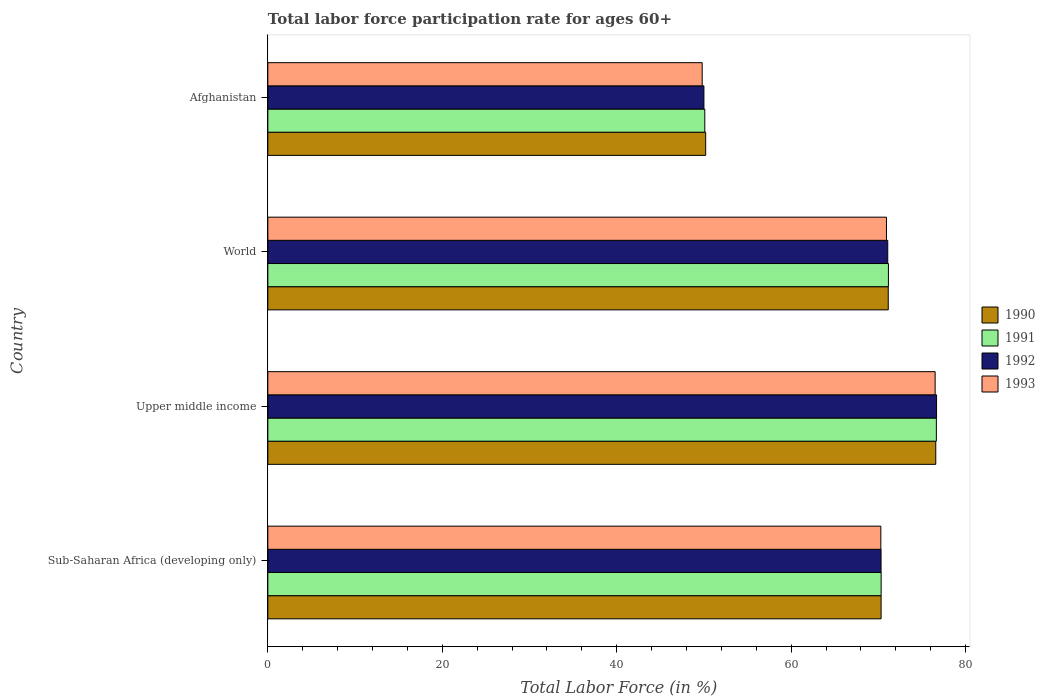How many different coloured bars are there?
Make the answer very short. 4. Are the number of bars per tick equal to the number of legend labels?
Your response must be concise. Yes. What is the label of the 4th group of bars from the top?
Provide a succinct answer. Sub-Saharan Africa (developing only). What is the labor force participation rate in 1991 in World?
Your answer should be compact. 71.15. Across all countries, what is the maximum labor force participation rate in 1993?
Make the answer very short. 76.51. Across all countries, what is the minimum labor force participation rate in 1993?
Offer a very short reply. 49.8. In which country was the labor force participation rate in 1990 maximum?
Give a very brief answer. Upper middle income. In which country was the labor force participation rate in 1991 minimum?
Give a very brief answer. Afghanistan. What is the total labor force participation rate in 1990 in the graph?
Offer a very short reply. 268.23. What is the difference between the labor force participation rate in 1990 in Upper middle income and that in World?
Offer a very short reply. 5.45. What is the difference between the labor force participation rate in 1993 in Sub-Saharan Africa (developing only) and the labor force participation rate in 1990 in Afghanistan?
Provide a short and direct response. 20.08. What is the average labor force participation rate in 1993 per country?
Your answer should be very brief. 66.88. What is the difference between the labor force participation rate in 1993 and labor force participation rate in 1991 in World?
Provide a succinct answer. -0.22. In how many countries, is the labor force participation rate in 1991 greater than 60 %?
Offer a terse response. 3. What is the ratio of the labor force participation rate in 1990 in Sub-Saharan Africa (developing only) to that in Upper middle income?
Keep it short and to the point. 0.92. Is the labor force participation rate in 1992 in Afghanistan less than that in World?
Provide a succinct answer. Yes. Is the difference between the labor force participation rate in 1993 in Afghanistan and World greater than the difference between the labor force participation rate in 1991 in Afghanistan and World?
Provide a short and direct response. No. What is the difference between the highest and the second highest labor force participation rate in 1992?
Your answer should be compact. 5.6. What is the difference between the highest and the lowest labor force participation rate in 1991?
Keep it short and to the point. 26.55. Is the sum of the labor force participation rate in 1992 in Sub-Saharan Africa (developing only) and Upper middle income greater than the maximum labor force participation rate in 1993 across all countries?
Provide a short and direct response. Yes. Is it the case that in every country, the sum of the labor force participation rate in 1993 and labor force participation rate in 1992 is greater than the sum of labor force participation rate in 1991 and labor force participation rate in 1990?
Provide a short and direct response. No. What does the 4th bar from the top in World represents?
Ensure brevity in your answer.  1990. What does the 1st bar from the bottom in Upper middle income represents?
Make the answer very short. 1990. Is it the case that in every country, the sum of the labor force participation rate in 1991 and labor force participation rate in 1993 is greater than the labor force participation rate in 1992?
Provide a succinct answer. Yes. How many bars are there?
Give a very brief answer. 16. Are all the bars in the graph horizontal?
Ensure brevity in your answer.  Yes. What is the difference between two consecutive major ticks on the X-axis?
Offer a terse response. 20. Does the graph contain any zero values?
Offer a terse response. No. Does the graph contain grids?
Give a very brief answer. No. How many legend labels are there?
Offer a terse response. 4. How are the legend labels stacked?
Your answer should be compact. Vertical. What is the title of the graph?
Your answer should be very brief. Total labor force participation rate for ages 60+. What is the label or title of the Y-axis?
Ensure brevity in your answer.  Country. What is the Total Labor Force (in %) of 1990 in Sub-Saharan Africa (developing only)?
Make the answer very short. 70.31. What is the Total Labor Force (in %) in 1991 in Sub-Saharan Africa (developing only)?
Your response must be concise. 70.32. What is the Total Labor Force (in %) in 1992 in Sub-Saharan Africa (developing only)?
Provide a succinct answer. 70.31. What is the Total Labor Force (in %) in 1993 in Sub-Saharan Africa (developing only)?
Make the answer very short. 70.28. What is the Total Labor Force (in %) in 1990 in Upper middle income?
Offer a terse response. 76.58. What is the Total Labor Force (in %) in 1991 in Upper middle income?
Offer a very short reply. 76.65. What is the Total Labor Force (in %) in 1992 in Upper middle income?
Provide a short and direct response. 76.67. What is the Total Labor Force (in %) in 1993 in Upper middle income?
Ensure brevity in your answer.  76.51. What is the Total Labor Force (in %) in 1990 in World?
Keep it short and to the point. 71.13. What is the Total Labor Force (in %) of 1991 in World?
Provide a succinct answer. 71.15. What is the Total Labor Force (in %) in 1992 in World?
Your response must be concise. 71.08. What is the Total Labor Force (in %) of 1993 in World?
Make the answer very short. 70.93. What is the Total Labor Force (in %) in 1990 in Afghanistan?
Offer a terse response. 50.2. What is the Total Labor Force (in %) of 1991 in Afghanistan?
Keep it short and to the point. 50.1. What is the Total Labor Force (in %) of 1992 in Afghanistan?
Your answer should be compact. 50. What is the Total Labor Force (in %) of 1993 in Afghanistan?
Provide a succinct answer. 49.8. Across all countries, what is the maximum Total Labor Force (in %) in 1990?
Offer a terse response. 76.58. Across all countries, what is the maximum Total Labor Force (in %) of 1991?
Offer a very short reply. 76.65. Across all countries, what is the maximum Total Labor Force (in %) of 1992?
Keep it short and to the point. 76.67. Across all countries, what is the maximum Total Labor Force (in %) in 1993?
Give a very brief answer. 76.51. Across all countries, what is the minimum Total Labor Force (in %) of 1990?
Your answer should be compact. 50.2. Across all countries, what is the minimum Total Labor Force (in %) in 1991?
Keep it short and to the point. 50.1. Across all countries, what is the minimum Total Labor Force (in %) of 1992?
Your answer should be very brief. 50. Across all countries, what is the minimum Total Labor Force (in %) of 1993?
Offer a very short reply. 49.8. What is the total Total Labor Force (in %) in 1990 in the graph?
Your answer should be compact. 268.23. What is the total Total Labor Force (in %) of 1991 in the graph?
Your response must be concise. 268.22. What is the total Total Labor Force (in %) in 1992 in the graph?
Your response must be concise. 268.06. What is the total Total Labor Force (in %) in 1993 in the graph?
Provide a short and direct response. 267.52. What is the difference between the Total Labor Force (in %) of 1990 in Sub-Saharan Africa (developing only) and that in Upper middle income?
Keep it short and to the point. -6.27. What is the difference between the Total Labor Force (in %) of 1991 in Sub-Saharan Africa (developing only) and that in Upper middle income?
Offer a terse response. -6.33. What is the difference between the Total Labor Force (in %) in 1992 in Sub-Saharan Africa (developing only) and that in Upper middle income?
Ensure brevity in your answer.  -6.36. What is the difference between the Total Labor Force (in %) of 1993 in Sub-Saharan Africa (developing only) and that in Upper middle income?
Offer a very short reply. -6.23. What is the difference between the Total Labor Force (in %) in 1990 in Sub-Saharan Africa (developing only) and that in World?
Your response must be concise. -0.82. What is the difference between the Total Labor Force (in %) of 1991 in Sub-Saharan Africa (developing only) and that in World?
Your answer should be very brief. -0.84. What is the difference between the Total Labor Force (in %) of 1992 in Sub-Saharan Africa (developing only) and that in World?
Provide a succinct answer. -0.77. What is the difference between the Total Labor Force (in %) of 1993 in Sub-Saharan Africa (developing only) and that in World?
Provide a succinct answer. -0.65. What is the difference between the Total Labor Force (in %) in 1990 in Sub-Saharan Africa (developing only) and that in Afghanistan?
Provide a short and direct response. 20.11. What is the difference between the Total Labor Force (in %) of 1991 in Sub-Saharan Africa (developing only) and that in Afghanistan?
Your answer should be very brief. 20.22. What is the difference between the Total Labor Force (in %) of 1992 in Sub-Saharan Africa (developing only) and that in Afghanistan?
Ensure brevity in your answer.  20.31. What is the difference between the Total Labor Force (in %) in 1993 in Sub-Saharan Africa (developing only) and that in Afghanistan?
Offer a terse response. 20.48. What is the difference between the Total Labor Force (in %) in 1990 in Upper middle income and that in World?
Keep it short and to the point. 5.45. What is the difference between the Total Labor Force (in %) of 1991 in Upper middle income and that in World?
Your answer should be very brief. 5.5. What is the difference between the Total Labor Force (in %) of 1992 in Upper middle income and that in World?
Provide a succinct answer. 5.6. What is the difference between the Total Labor Force (in %) in 1993 in Upper middle income and that in World?
Make the answer very short. 5.58. What is the difference between the Total Labor Force (in %) in 1990 in Upper middle income and that in Afghanistan?
Provide a short and direct response. 26.38. What is the difference between the Total Labor Force (in %) in 1991 in Upper middle income and that in Afghanistan?
Keep it short and to the point. 26.55. What is the difference between the Total Labor Force (in %) of 1992 in Upper middle income and that in Afghanistan?
Offer a very short reply. 26.67. What is the difference between the Total Labor Force (in %) of 1993 in Upper middle income and that in Afghanistan?
Your answer should be compact. 26.71. What is the difference between the Total Labor Force (in %) of 1990 in World and that in Afghanistan?
Ensure brevity in your answer.  20.93. What is the difference between the Total Labor Force (in %) of 1991 in World and that in Afghanistan?
Ensure brevity in your answer.  21.05. What is the difference between the Total Labor Force (in %) in 1992 in World and that in Afghanistan?
Offer a terse response. 21.08. What is the difference between the Total Labor Force (in %) of 1993 in World and that in Afghanistan?
Offer a very short reply. 21.13. What is the difference between the Total Labor Force (in %) in 1990 in Sub-Saharan Africa (developing only) and the Total Labor Force (in %) in 1991 in Upper middle income?
Keep it short and to the point. -6.34. What is the difference between the Total Labor Force (in %) in 1990 in Sub-Saharan Africa (developing only) and the Total Labor Force (in %) in 1992 in Upper middle income?
Keep it short and to the point. -6.36. What is the difference between the Total Labor Force (in %) of 1990 in Sub-Saharan Africa (developing only) and the Total Labor Force (in %) of 1993 in Upper middle income?
Offer a terse response. -6.19. What is the difference between the Total Labor Force (in %) in 1991 in Sub-Saharan Africa (developing only) and the Total Labor Force (in %) in 1992 in Upper middle income?
Your answer should be very brief. -6.35. What is the difference between the Total Labor Force (in %) of 1991 in Sub-Saharan Africa (developing only) and the Total Labor Force (in %) of 1993 in Upper middle income?
Ensure brevity in your answer.  -6.19. What is the difference between the Total Labor Force (in %) of 1992 in Sub-Saharan Africa (developing only) and the Total Labor Force (in %) of 1993 in Upper middle income?
Give a very brief answer. -6.2. What is the difference between the Total Labor Force (in %) of 1990 in Sub-Saharan Africa (developing only) and the Total Labor Force (in %) of 1991 in World?
Offer a very short reply. -0.84. What is the difference between the Total Labor Force (in %) in 1990 in Sub-Saharan Africa (developing only) and the Total Labor Force (in %) in 1992 in World?
Provide a succinct answer. -0.76. What is the difference between the Total Labor Force (in %) of 1990 in Sub-Saharan Africa (developing only) and the Total Labor Force (in %) of 1993 in World?
Provide a succinct answer. -0.61. What is the difference between the Total Labor Force (in %) in 1991 in Sub-Saharan Africa (developing only) and the Total Labor Force (in %) in 1992 in World?
Offer a terse response. -0.76. What is the difference between the Total Labor Force (in %) in 1991 in Sub-Saharan Africa (developing only) and the Total Labor Force (in %) in 1993 in World?
Give a very brief answer. -0.61. What is the difference between the Total Labor Force (in %) of 1992 in Sub-Saharan Africa (developing only) and the Total Labor Force (in %) of 1993 in World?
Make the answer very short. -0.62. What is the difference between the Total Labor Force (in %) in 1990 in Sub-Saharan Africa (developing only) and the Total Labor Force (in %) in 1991 in Afghanistan?
Offer a very short reply. 20.21. What is the difference between the Total Labor Force (in %) in 1990 in Sub-Saharan Africa (developing only) and the Total Labor Force (in %) in 1992 in Afghanistan?
Your answer should be very brief. 20.31. What is the difference between the Total Labor Force (in %) of 1990 in Sub-Saharan Africa (developing only) and the Total Labor Force (in %) of 1993 in Afghanistan?
Offer a terse response. 20.51. What is the difference between the Total Labor Force (in %) of 1991 in Sub-Saharan Africa (developing only) and the Total Labor Force (in %) of 1992 in Afghanistan?
Provide a succinct answer. 20.32. What is the difference between the Total Labor Force (in %) of 1991 in Sub-Saharan Africa (developing only) and the Total Labor Force (in %) of 1993 in Afghanistan?
Provide a short and direct response. 20.52. What is the difference between the Total Labor Force (in %) in 1992 in Sub-Saharan Africa (developing only) and the Total Labor Force (in %) in 1993 in Afghanistan?
Ensure brevity in your answer.  20.51. What is the difference between the Total Labor Force (in %) of 1990 in Upper middle income and the Total Labor Force (in %) of 1991 in World?
Offer a very short reply. 5.43. What is the difference between the Total Labor Force (in %) in 1990 in Upper middle income and the Total Labor Force (in %) in 1992 in World?
Offer a terse response. 5.51. What is the difference between the Total Labor Force (in %) of 1990 in Upper middle income and the Total Labor Force (in %) of 1993 in World?
Your answer should be compact. 5.65. What is the difference between the Total Labor Force (in %) in 1991 in Upper middle income and the Total Labor Force (in %) in 1992 in World?
Your answer should be compact. 5.57. What is the difference between the Total Labor Force (in %) in 1991 in Upper middle income and the Total Labor Force (in %) in 1993 in World?
Your answer should be very brief. 5.72. What is the difference between the Total Labor Force (in %) in 1992 in Upper middle income and the Total Labor Force (in %) in 1993 in World?
Offer a very short reply. 5.74. What is the difference between the Total Labor Force (in %) of 1990 in Upper middle income and the Total Labor Force (in %) of 1991 in Afghanistan?
Provide a short and direct response. 26.48. What is the difference between the Total Labor Force (in %) of 1990 in Upper middle income and the Total Labor Force (in %) of 1992 in Afghanistan?
Your answer should be compact. 26.58. What is the difference between the Total Labor Force (in %) in 1990 in Upper middle income and the Total Labor Force (in %) in 1993 in Afghanistan?
Offer a terse response. 26.78. What is the difference between the Total Labor Force (in %) of 1991 in Upper middle income and the Total Labor Force (in %) of 1992 in Afghanistan?
Give a very brief answer. 26.65. What is the difference between the Total Labor Force (in %) in 1991 in Upper middle income and the Total Labor Force (in %) in 1993 in Afghanistan?
Offer a very short reply. 26.85. What is the difference between the Total Labor Force (in %) of 1992 in Upper middle income and the Total Labor Force (in %) of 1993 in Afghanistan?
Keep it short and to the point. 26.87. What is the difference between the Total Labor Force (in %) in 1990 in World and the Total Labor Force (in %) in 1991 in Afghanistan?
Give a very brief answer. 21.03. What is the difference between the Total Labor Force (in %) in 1990 in World and the Total Labor Force (in %) in 1992 in Afghanistan?
Provide a short and direct response. 21.13. What is the difference between the Total Labor Force (in %) in 1990 in World and the Total Labor Force (in %) in 1993 in Afghanistan?
Keep it short and to the point. 21.33. What is the difference between the Total Labor Force (in %) in 1991 in World and the Total Labor Force (in %) in 1992 in Afghanistan?
Your answer should be compact. 21.15. What is the difference between the Total Labor Force (in %) in 1991 in World and the Total Labor Force (in %) in 1993 in Afghanistan?
Ensure brevity in your answer.  21.35. What is the difference between the Total Labor Force (in %) of 1992 in World and the Total Labor Force (in %) of 1993 in Afghanistan?
Give a very brief answer. 21.28. What is the average Total Labor Force (in %) of 1990 per country?
Provide a short and direct response. 67.06. What is the average Total Labor Force (in %) in 1991 per country?
Provide a succinct answer. 67.06. What is the average Total Labor Force (in %) in 1992 per country?
Keep it short and to the point. 67.01. What is the average Total Labor Force (in %) in 1993 per country?
Your answer should be very brief. 66.88. What is the difference between the Total Labor Force (in %) in 1990 and Total Labor Force (in %) in 1991 in Sub-Saharan Africa (developing only)?
Keep it short and to the point. -0. What is the difference between the Total Labor Force (in %) in 1990 and Total Labor Force (in %) in 1992 in Sub-Saharan Africa (developing only)?
Your response must be concise. 0.01. What is the difference between the Total Labor Force (in %) in 1990 and Total Labor Force (in %) in 1993 in Sub-Saharan Africa (developing only)?
Your answer should be very brief. 0.03. What is the difference between the Total Labor Force (in %) of 1991 and Total Labor Force (in %) of 1992 in Sub-Saharan Africa (developing only)?
Your answer should be very brief. 0.01. What is the difference between the Total Labor Force (in %) in 1991 and Total Labor Force (in %) in 1993 in Sub-Saharan Africa (developing only)?
Your answer should be very brief. 0.03. What is the difference between the Total Labor Force (in %) in 1992 and Total Labor Force (in %) in 1993 in Sub-Saharan Africa (developing only)?
Provide a succinct answer. 0.03. What is the difference between the Total Labor Force (in %) of 1990 and Total Labor Force (in %) of 1991 in Upper middle income?
Offer a terse response. -0.07. What is the difference between the Total Labor Force (in %) of 1990 and Total Labor Force (in %) of 1992 in Upper middle income?
Provide a short and direct response. -0.09. What is the difference between the Total Labor Force (in %) in 1990 and Total Labor Force (in %) in 1993 in Upper middle income?
Provide a short and direct response. 0.07. What is the difference between the Total Labor Force (in %) of 1991 and Total Labor Force (in %) of 1992 in Upper middle income?
Your answer should be compact. -0.02. What is the difference between the Total Labor Force (in %) in 1991 and Total Labor Force (in %) in 1993 in Upper middle income?
Give a very brief answer. 0.14. What is the difference between the Total Labor Force (in %) of 1992 and Total Labor Force (in %) of 1993 in Upper middle income?
Keep it short and to the point. 0.16. What is the difference between the Total Labor Force (in %) of 1990 and Total Labor Force (in %) of 1991 in World?
Your answer should be compact. -0.02. What is the difference between the Total Labor Force (in %) of 1990 and Total Labor Force (in %) of 1992 in World?
Your response must be concise. 0.06. What is the difference between the Total Labor Force (in %) in 1990 and Total Labor Force (in %) in 1993 in World?
Ensure brevity in your answer.  0.2. What is the difference between the Total Labor Force (in %) in 1991 and Total Labor Force (in %) in 1992 in World?
Your answer should be compact. 0.08. What is the difference between the Total Labor Force (in %) of 1991 and Total Labor Force (in %) of 1993 in World?
Give a very brief answer. 0.22. What is the difference between the Total Labor Force (in %) of 1992 and Total Labor Force (in %) of 1993 in World?
Offer a terse response. 0.15. What is the difference between the Total Labor Force (in %) of 1990 and Total Labor Force (in %) of 1991 in Afghanistan?
Make the answer very short. 0.1. What is the difference between the Total Labor Force (in %) in 1990 and Total Labor Force (in %) in 1992 in Afghanistan?
Offer a very short reply. 0.2. What is the difference between the Total Labor Force (in %) in 1990 and Total Labor Force (in %) in 1993 in Afghanistan?
Give a very brief answer. 0.4. What is the ratio of the Total Labor Force (in %) in 1990 in Sub-Saharan Africa (developing only) to that in Upper middle income?
Provide a succinct answer. 0.92. What is the ratio of the Total Labor Force (in %) of 1991 in Sub-Saharan Africa (developing only) to that in Upper middle income?
Give a very brief answer. 0.92. What is the ratio of the Total Labor Force (in %) in 1992 in Sub-Saharan Africa (developing only) to that in Upper middle income?
Give a very brief answer. 0.92. What is the ratio of the Total Labor Force (in %) in 1993 in Sub-Saharan Africa (developing only) to that in Upper middle income?
Give a very brief answer. 0.92. What is the ratio of the Total Labor Force (in %) in 1991 in Sub-Saharan Africa (developing only) to that in World?
Offer a very short reply. 0.99. What is the ratio of the Total Labor Force (in %) in 1993 in Sub-Saharan Africa (developing only) to that in World?
Ensure brevity in your answer.  0.99. What is the ratio of the Total Labor Force (in %) in 1990 in Sub-Saharan Africa (developing only) to that in Afghanistan?
Make the answer very short. 1.4. What is the ratio of the Total Labor Force (in %) in 1991 in Sub-Saharan Africa (developing only) to that in Afghanistan?
Your response must be concise. 1.4. What is the ratio of the Total Labor Force (in %) in 1992 in Sub-Saharan Africa (developing only) to that in Afghanistan?
Give a very brief answer. 1.41. What is the ratio of the Total Labor Force (in %) in 1993 in Sub-Saharan Africa (developing only) to that in Afghanistan?
Offer a terse response. 1.41. What is the ratio of the Total Labor Force (in %) of 1990 in Upper middle income to that in World?
Your answer should be very brief. 1.08. What is the ratio of the Total Labor Force (in %) in 1991 in Upper middle income to that in World?
Your answer should be very brief. 1.08. What is the ratio of the Total Labor Force (in %) of 1992 in Upper middle income to that in World?
Keep it short and to the point. 1.08. What is the ratio of the Total Labor Force (in %) of 1993 in Upper middle income to that in World?
Give a very brief answer. 1.08. What is the ratio of the Total Labor Force (in %) in 1990 in Upper middle income to that in Afghanistan?
Your answer should be compact. 1.53. What is the ratio of the Total Labor Force (in %) in 1991 in Upper middle income to that in Afghanistan?
Keep it short and to the point. 1.53. What is the ratio of the Total Labor Force (in %) in 1992 in Upper middle income to that in Afghanistan?
Provide a succinct answer. 1.53. What is the ratio of the Total Labor Force (in %) of 1993 in Upper middle income to that in Afghanistan?
Make the answer very short. 1.54. What is the ratio of the Total Labor Force (in %) of 1990 in World to that in Afghanistan?
Provide a short and direct response. 1.42. What is the ratio of the Total Labor Force (in %) of 1991 in World to that in Afghanistan?
Your response must be concise. 1.42. What is the ratio of the Total Labor Force (in %) of 1992 in World to that in Afghanistan?
Provide a short and direct response. 1.42. What is the ratio of the Total Labor Force (in %) of 1993 in World to that in Afghanistan?
Offer a terse response. 1.42. What is the difference between the highest and the second highest Total Labor Force (in %) in 1990?
Make the answer very short. 5.45. What is the difference between the highest and the second highest Total Labor Force (in %) in 1991?
Your answer should be compact. 5.5. What is the difference between the highest and the second highest Total Labor Force (in %) of 1992?
Your answer should be very brief. 5.6. What is the difference between the highest and the second highest Total Labor Force (in %) in 1993?
Offer a terse response. 5.58. What is the difference between the highest and the lowest Total Labor Force (in %) of 1990?
Ensure brevity in your answer.  26.38. What is the difference between the highest and the lowest Total Labor Force (in %) in 1991?
Ensure brevity in your answer.  26.55. What is the difference between the highest and the lowest Total Labor Force (in %) in 1992?
Your answer should be very brief. 26.67. What is the difference between the highest and the lowest Total Labor Force (in %) of 1993?
Provide a short and direct response. 26.71. 